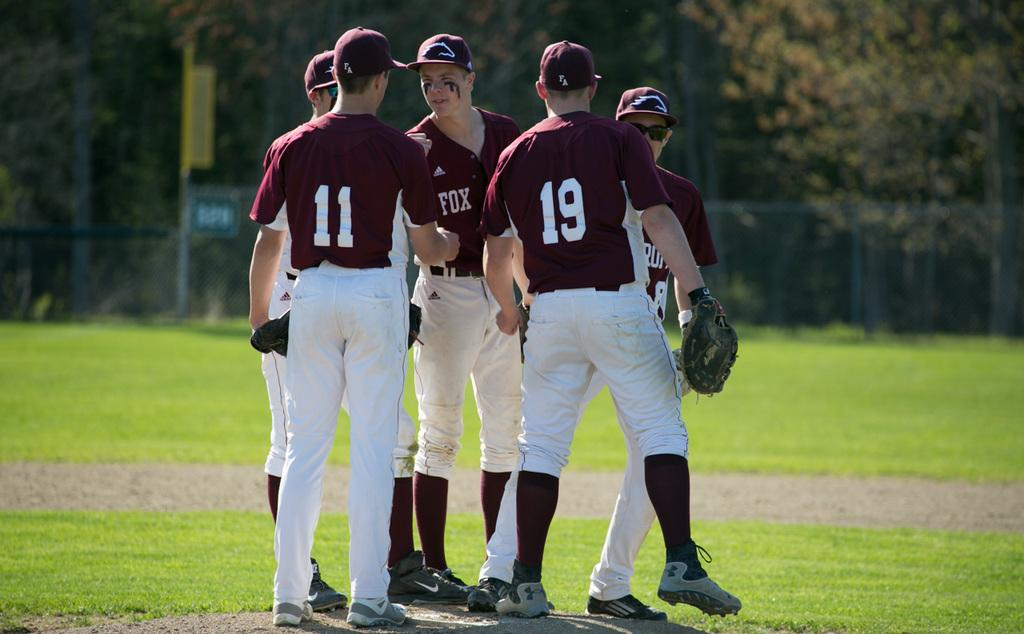<image>
Share a concise interpretation of the image provided. Several baseball players are standing in a circle including player numbers 11 and 19. 